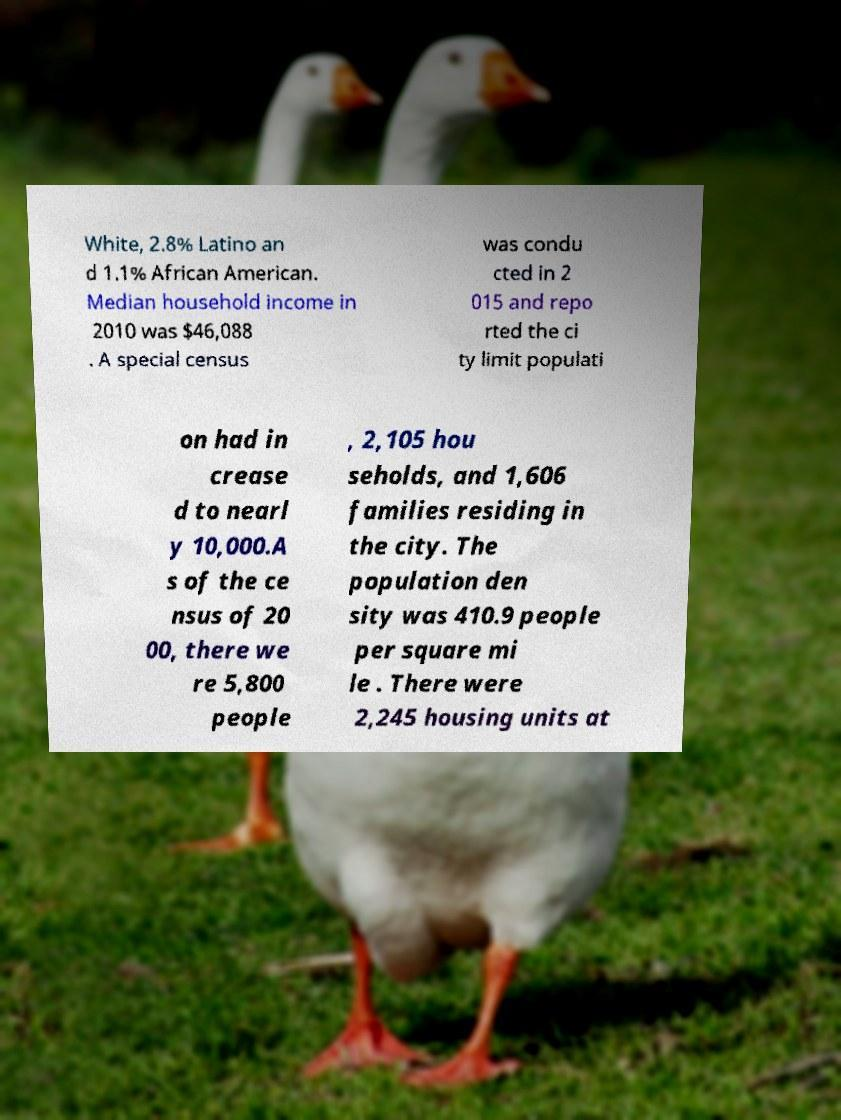Please identify and transcribe the text found in this image. White, 2.8% Latino an d 1.1% African American. Median household income in 2010 was $46,088 . A special census was condu cted in 2 015 and repo rted the ci ty limit populati on had in crease d to nearl y 10,000.A s of the ce nsus of 20 00, there we re 5,800 people , 2,105 hou seholds, and 1,606 families residing in the city. The population den sity was 410.9 people per square mi le . There were 2,245 housing units at 